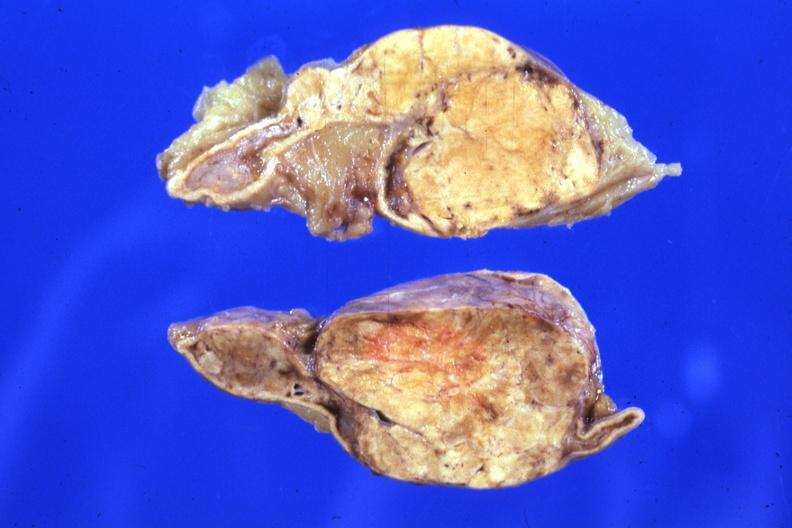what is present?
Answer the question using a single word or phrase. Endocrine 